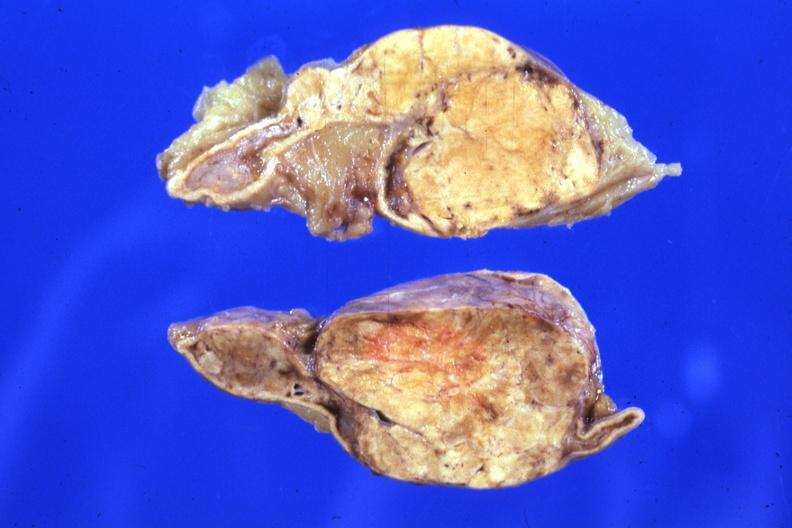what is present?
Answer the question using a single word or phrase. Endocrine 